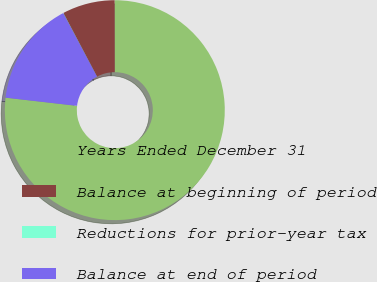Convert chart to OTSL. <chart><loc_0><loc_0><loc_500><loc_500><pie_chart><fcel>Years Ended December 31<fcel>Balance at beginning of period<fcel>Reductions for prior-year tax<fcel>Balance at end of period<nl><fcel>76.84%<fcel>7.72%<fcel>0.04%<fcel>15.4%<nl></chart> 